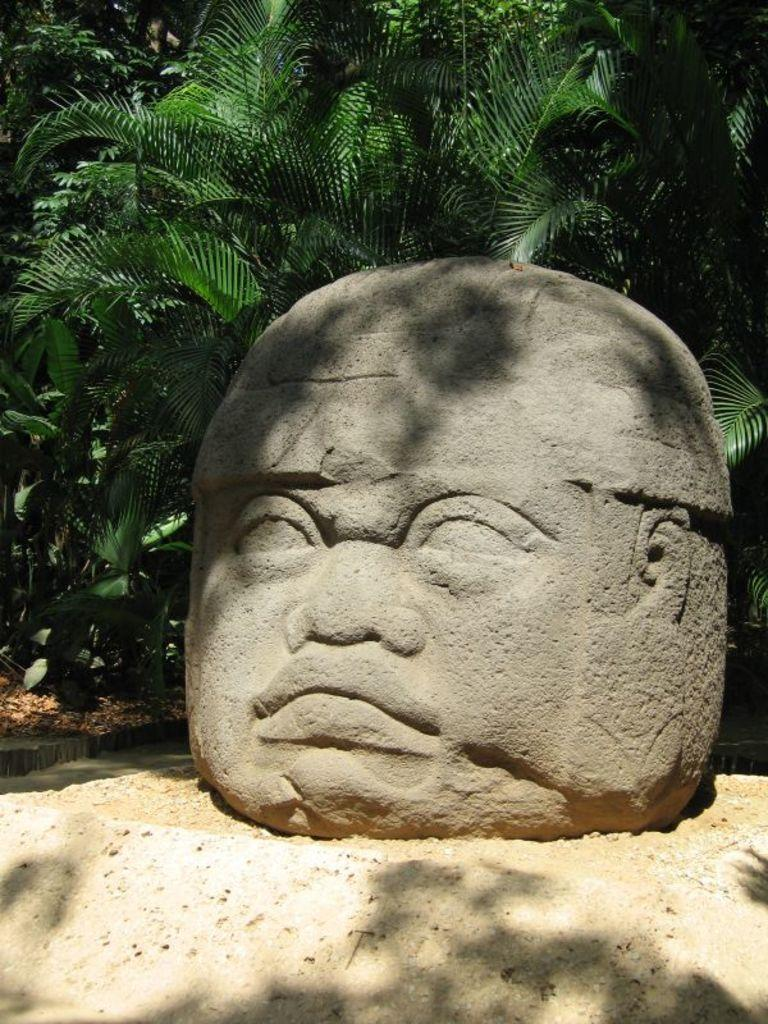What is depicted on the rock in the image? There is a person's face figure on a rock in the image. Where is the rock located? The rock is on the ground. What can be seen in the background of the image? There are plants and trees in the background of the image. How many pizzas are being served on the rock in the image? There are no pizzas present in the image; it features a person's face figure on a rock. What is the person's temper like in the image? There is no indication of the person's temper in the image, as it only shows their face figure on a rock. 